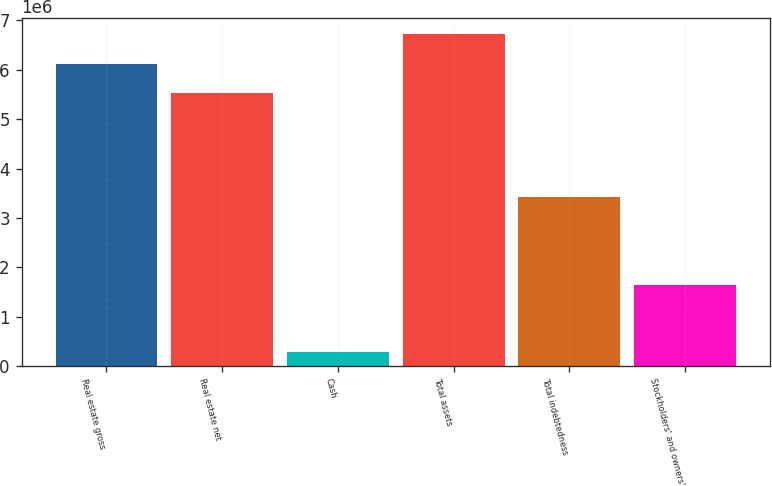Convert chart to OTSL. <chart><loc_0><loc_0><loc_500><loc_500><bar_chart><fcel>Real estate gross<fcel>Real estate net<fcel>Cash<fcel>Total assets<fcel>Total indebtedness<fcel>Stockholders' and owners'<nl><fcel>6.12061e+06<fcel>5.52606e+06<fcel>280957<fcel>6.71516e+06<fcel>3.41489e+06<fcel>1.64773e+06<nl></chart> 